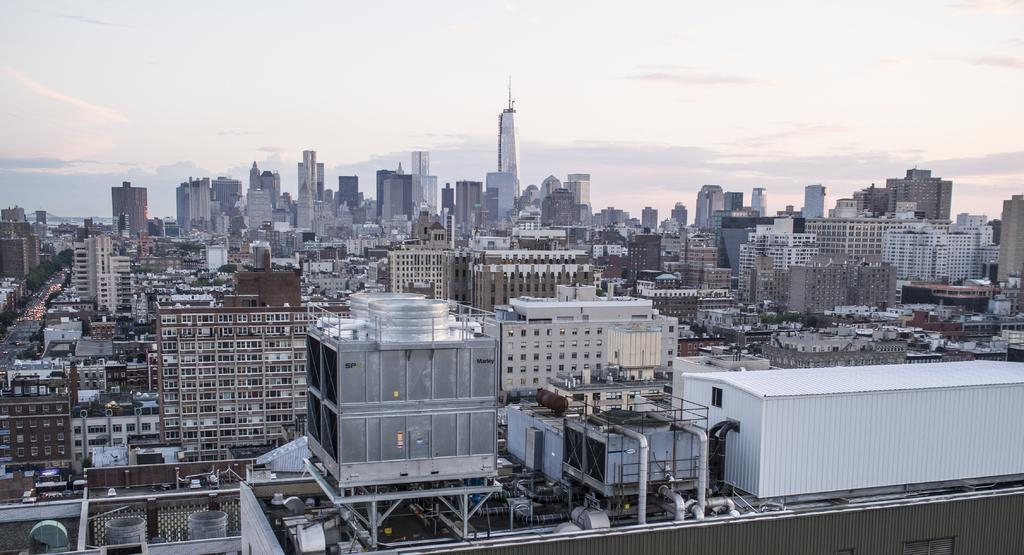What type of view is shown in the image? The image is an aerial view. What can be seen in the image from this perspective? There are many buildings and cars visible in the image. What is the purpose of the road in the image? The road is likely used for transportation and connecting different areas in the image. What is visible in the background of the image? The sky is visible in the background of the image. What type of exchange is taking place between the buildings in the image? There is no exchange taking place between the buildings in the image; it is a still image of an aerial view. What kind of apparatus is used to capture the image from such a high angle? The image does not provide information about the apparatus used to capture it; it only shows the aerial view itself. 